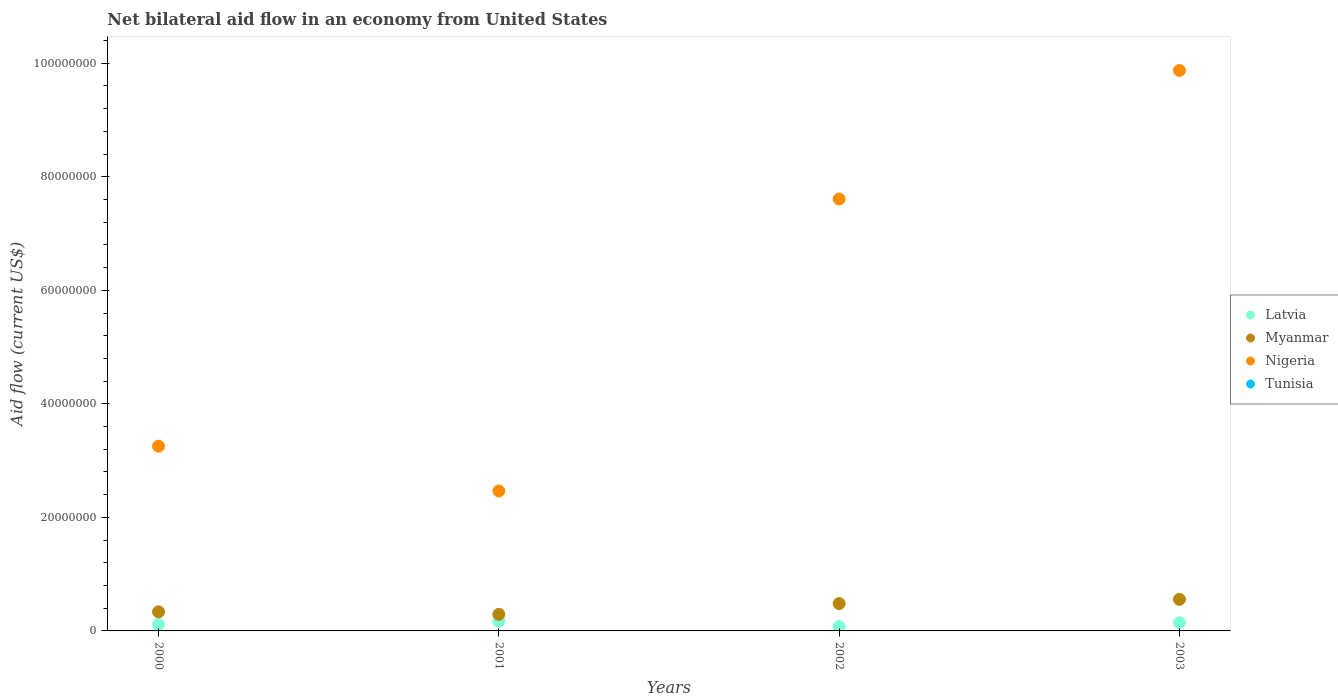How many different coloured dotlines are there?
Offer a terse response. 3. What is the net bilateral aid flow in Myanmar in 2001?
Provide a short and direct response. 2.93e+06. Across all years, what is the maximum net bilateral aid flow in Myanmar?
Provide a succinct answer. 5.56e+06. Across all years, what is the minimum net bilateral aid flow in Myanmar?
Make the answer very short. 2.93e+06. In which year was the net bilateral aid flow in Nigeria maximum?
Ensure brevity in your answer.  2003. What is the difference between the net bilateral aid flow in Tunisia in 2003 and the net bilateral aid flow in Nigeria in 2000?
Your response must be concise. -3.25e+07. What is the average net bilateral aid flow in Latvia per year?
Provide a succinct answer. 1.28e+06. In the year 2001, what is the difference between the net bilateral aid flow in Myanmar and net bilateral aid flow in Latvia?
Your answer should be very brief. 1.22e+06. In how many years, is the net bilateral aid flow in Latvia greater than 16000000 US$?
Offer a terse response. 0. What is the ratio of the net bilateral aid flow in Myanmar in 2000 to that in 2002?
Keep it short and to the point. 0.7. Is the difference between the net bilateral aid flow in Myanmar in 2001 and 2002 greater than the difference between the net bilateral aid flow in Latvia in 2001 and 2002?
Ensure brevity in your answer.  No. What is the difference between the highest and the second highest net bilateral aid flow in Nigeria?
Your answer should be compact. 2.26e+07. What is the difference between the highest and the lowest net bilateral aid flow in Myanmar?
Your answer should be compact. 2.63e+06. In how many years, is the net bilateral aid flow in Tunisia greater than the average net bilateral aid flow in Tunisia taken over all years?
Ensure brevity in your answer.  0. Is the sum of the net bilateral aid flow in Myanmar in 2001 and 2003 greater than the maximum net bilateral aid flow in Nigeria across all years?
Offer a terse response. No. Is it the case that in every year, the sum of the net bilateral aid flow in Nigeria and net bilateral aid flow in Myanmar  is greater than the sum of net bilateral aid flow in Tunisia and net bilateral aid flow in Latvia?
Provide a succinct answer. Yes. How many dotlines are there?
Provide a short and direct response. 3. How many years are there in the graph?
Your answer should be very brief. 4. What is the difference between two consecutive major ticks on the Y-axis?
Keep it short and to the point. 2.00e+07. How many legend labels are there?
Make the answer very short. 4. How are the legend labels stacked?
Ensure brevity in your answer.  Vertical. What is the title of the graph?
Your response must be concise. Net bilateral aid flow in an economy from United States. What is the Aid flow (current US$) in Latvia in 2000?
Offer a terse response. 1.15e+06. What is the Aid flow (current US$) in Myanmar in 2000?
Provide a short and direct response. 3.36e+06. What is the Aid flow (current US$) in Nigeria in 2000?
Your response must be concise. 3.25e+07. What is the Aid flow (current US$) of Tunisia in 2000?
Give a very brief answer. 0. What is the Aid flow (current US$) of Latvia in 2001?
Provide a succinct answer. 1.71e+06. What is the Aid flow (current US$) in Myanmar in 2001?
Your answer should be very brief. 2.93e+06. What is the Aid flow (current US$) in Nigeria in 2001?
Your answer should be very brief. 2.46e+07. What is the Aid flow (current US$) of Latvia in 2002?
Offer a very short reply. 8.10e+05. What is the Aid flow (current US$) in Myanmar in 2002?
Your response must be concise. 4.82e+06. What is the Aid flow (current US$) of Nigeria in 2002?
Ensure brevity in your answer.  7.61e+07. What is the Aid flow (current US$) of Latvia in 2003?
Provide a short and direct response. 1.45e+06. What is the Aid flow (current US$) of Myanmar in 2003?
Offer a very short reply. 5.56e+06. What is the Aid flow (current US$) in Nigeria in 2003?
Give a very brief answer. 9.87e+07. Across all years, what is the maximum Aid flow (current US$) in Latvia?
Keep it short and to the point. 1.71e+06. Across all years, what is the maximum Aid flow (current US$) of Myanmar?
Provide a short and direct response. 5.56e+06. Across all years, what is the maximum Aid flow (current US$) in Nigeria?
Make the answer very short. 9.87e+07. Across all years, what is the minimum Aid flow (current US$) in Latvia?
Give a very brief answer. 8.10e+05. Across all years, what is the minimum Aid flow (current US$) in Myanmar?
Provide a short and direct response. 2.93e+06. Across all years, what is the minimum Aid flow (current US$) in Nigeria?
Your response must be concise. 2.46e+07. What is the total Aid flow (current US$) in Latvia in the graph?
Offer a terse response. 5.12e+06. What is the total Aid flow (current US$) of Myanmar in the graph?
Make the answer very short. 1.67e+07. What is the total Aid flow (current US$) in Nigeria in the graph?
Ensure brevity in your answer.  2.32e+08. What is the total Aid flow (current US$) of Tunisia in the graph?
Give a very brief answer. 0. What is the difference between the Aid flow (current US$) of Latvia in 2000 and that in 2001?
Ensure brevity in your answer.  -5.60e+05. What is the difference between the Aid flow (current US$) in Nigeria in 2000 and that in 2001?
Make the answer very short. 7.88e+06. What is the difference between the Aid flow (current US$) of Latvia in 2000 and that in 2002?
Your answer should be compact. 3.40e+05. What is the difference between the Aid flow (current US$) in Myanmar in 2000 and that in 2002?
Your response must be concise. -1.46e+06. What is the difference between the Aid flow (current US$) in Nigeria in 2000 and that in 2002?
Your answer should be very brief. -4.36e+07. What is the difference between the Aid flow (current US$) in Myanmar in 2000 and that in 2003?
Make the answer very short. -2.20e+06. What is the difference between the Aid flow (current US$) of Nigeria in 2000 and that in 2003?
Your answer should be compact. -6.62e+07. What is the difference between the Aid flow (current US$) in Myanmar in 2001 and that in 2002?
Your answer should be very brief. -1.89e+06. What is the difference between the Aid flow (current US$) in Nigeria in 2001 and that in 2002?
Ensure brevity in your answer.  -5.14e+07. What is the difference between the Aid flow (current US$) in Myanmar in 2001 and that in 2003?
Ensure brevity in your answer.  -2.63e+06. What is the difference between the Aid flow (current US$) of Nigeria in 2001 and that in 2003?
Offer a very short reply. -7.41e+07. What is the difference between the Aid flow (current US$) of Latvia in 2002 and that in 2003?
Give a very brief answer. -6.40e+05. What is the difference between the Aid flow (current US$) in Myanmar in 2002 and that in 2003?
Provide a succinct answer. -7.40e+05. What is the difference between the Aid flow (current US$) in Nigeria in 2002 and that in 2003?
Your answer should be very brief. -2.26e+07. What is the difference between the Aid flow (current US$) of Latvia in 2000 and the Aid flow (current US$) of Myanmar in 2001?
Provide a short and direct response. -1.78e+06. What is the difference between the Aid flow (current US$) of Latvia in 2000 and the Aid flow (current US$) of Nigeria in 2001?
Keep it short and to the point. -2.35e+07. What is the difference between the Aid flow (current US$) of Myanmar in 2000 and the Aid flow (current US$) of Nigeria in 2001?
Your answer should be compact. -2.13e+07. What is the difference between the Aid flow (current US$) in Latvia in 2000 and the Aid flow (current US$) in Myanmar in 2002?
Your response must be concise. -3.67e+06. What is the difference between the Aid flow (current US$) of Latvia in 2000 and the Aid flow (current US$) of Nigeria in 2002?
Offer a terse response. -7.49e+07. What is the difference between the Aid flow (current US$) of Myanmar in 2000 and the Aid flow (current US$) of Nigeria in 2002?
Give a very brief answer. -7.27e+07. What is the difference between the Aid flow (current US$) in Latvia in 2000 and the Aid flow (current US$) in Myanmar in 2003?
Your answer should be compact. -4.41e+06. What is the difference between the Aid flow (current US$) in Latvia in 2000 and the Aid flow (current US$) in Nigeria in 2003?
Make the answer very short. -9.76e+07. What is the difference between the Aid flow (current US$) in Myanmar in 2000 and the Aid flow (current US$) in Nigeria in 2003?
Your response must be concise. -9.54e+07. What is the difference between the Aid flow (current US$) in Latvia in 2001 and the Aid flow (current US$) in Myanmar in 2002?
Offer a very short reply. -3.11e+06. What is the difference between the Aid flow (current US$) of Latvia in 2001 and the Aid flow (current US$) of Nigeria in 2002?
Offer a very short reply. -7.44e+07. What is the difference between the Aid flow (current US$) of Myanmar in 2001 and the Aid flow (current US$) of Nigeria in 2002?
Offer a very short reply. -7.32e+07. What is the difference between the Aid flow (current US$) in Latvia in 2001 and the Aid flow (current US$) in Myanmar in 2003?
Provide a short and direct response. -3.85e+06. What is the difference between the Aid flow (current US$) of Latvia in 2001 and the Aid flow (current US$) of Nigeria in 2003?
Your answer should be very brief. -9.70e+07. What is the difference between the Aid flow (current US$) in Myanmar in 2001 and the Aid flow (current US$) in Nigeria in 2003?
Offer a very short reply. -9.58e+07. What is the difference between the Aid flow (current US$) of Latvia in 2002 and the Aid flow (current US$) of Myanmar in 2003?
Give a very brief answer. -4.75e+06. What is the difference between the Aid flow (current US$) of Latvia in 2002 and the Aid flow (current US$) of Nigeria in 2003?
Your response must be concise. -9.79e+07. What is the difference between the Aid flow (current US$) in Myanmar in 2002 and the Aid flow (current US$) in Nigeria in 2003?
Your answer should be very brief. -9.39e+07. What is the average Aid flow (current US$) of Latvia per year?
Ensure brevity in your answer.  1.28e+06. What is the average Aid flow (current US$) of Myanmar per year?
Your answer should be very brief. 4.17e+06. What is the average Aid flow (current US$) of Nigeria per year?
Give a very brief answer. 5.80e+07. In the year 2000, what is the difference between the Aid flow (current US$) in Latvia and Aid flow (current US$) in Myanmar?
Ensure brevity in your answer.  -2.21e+06. In the year 2000, what is the difference between the Aid flow (current US$) of Latvia and Aid flow (current US$) of Nigeria?
Provide a short and direct response. -3.14e+07. In the year 2000, what is the difference between the Aid flow (current US$) of Myanmar and Aid flow (current US$) of Nigeria?
Offer a terse response. -2.92e+07. In the year 2001, what is the difference between the Aid flow (current US$) in Latvia and Aid flow (current US$) in Myanmar?
Offer a terse response. -1.22e+06. In the year 2001, what is the difference between the Aid flow (current US$) in Latvia and Aid flow (current US$) in Nigeria?
Provide a short and direct response. -2.29e+07. In the year 2001, what is the difference between the Aid flow (current US$) in Myanmar and Aid flow (current US$) in Nigeria?
Give a very brief answer. -2.17e+07. In the year 2002, what is the difference between the Aid flow (current US$) in Latvia and Aid flow (current US$) in Myanmar?
Your answer should be compact. -4.01e+06. In the year 2002, what is the difference between the Aid flow (current US$) of Latvia and Aid flow (current US$) of Nigeria?
Provide a short and direct response. -7.53e+07. In the year 2002, what is the difference between the Aid flow (current US$) in Myanmar and Aid flow (current US$) in Nigeria?
Your answer should be very brief. -7.13e+07. In the year 2003, what is the difference between the Aid flow (current US$) of Latvia and Aid flow (current US$) of Myanmar?
Make the answer very short. -4.11e+06. In the year 2003, what is the difference between the Aid flow (current US$) of Latvia and Aid flow (current US$) of Nigeria?
Your response must be concise. -9.73e+07. In the year 2003, what is the difference between the Aid flow (current US$) in Myanmar and Aid flow (current US$) in Nigeria?
Provide a succinct answer. -9.32e+07. What is the ratio of the Aid flow (current US$) in Latvia in 2000 to that in 2001?
Keep it short and to the point. 0.67. What is the ratio of the Aid flow (current US$) of Myanmar in 2000 to that in 2001?
Keep it short and to the point. 1.15. What is the ratio of the Aid flow (current US$) in Nigeria in 2000 to that in 2001?
Keep it short and to the point. 1.32. What is the ratio of the Aid flow (current US$) in Latvia in 2000 to that in 2002?
Provide a short and direct response. 1.42. What is the ratio of the Aid flow (current US$) of Myanmar in 2000 to that in 2002?
Ensure brevity in your answer.  0.7. What is the ratio of the Aid flow (current US$) of Nigeria in 2000 to that in 2002?
Your response must be concise. 0.43. What is the ratio of the Aid flow (current US$) of Latvia in 2000 to that in 2003?
Keep it short and to the point. 0.79. What is the ratio of the Aid flow (current US$) of Myanmar in 2000 to that in 2003?
Keep it short and to the point. 0.6. What is the ratio of the Aid flow (current US$) in Nigeria in 2000 to that in 2003?
Offer a terse response. 0.33. What is the ratio of the Aid flow (current US$) in Latvia in 2001 to that in 2002?
Offer a very short reply. 2.11. What is the ratio of the Aid flow (current US$) in Myanmar in 2001 to that in 2002?
Provide a succinct answer. 0.61. What is the ratio of the Aid flow (current US$) of Nigeria in 2001 to that in 2002?
Provide a short and direct response. 0.32. What is the ratio of the Aid flow (current US$) in Latvia in 2001 to that in 2003?
Ensure brevity in your answer.  1.18. What is the ratio of the Aid flow (current US$) in Myanmar in 2001 to that in 2003?
Your response must be concise. 0.53. What is the ratio of the Aid flow (current US$) of Nigeria in 2001 to that in 2003?
Ensure brevity in your answer.  0.25. What is the ratio of the Aid flow (current US$) in Latvia in 2002 to that in 2003?
Offer a very short reply. 0.56. What is the ratio of the Aid flow (current US$) of Myanmar in 2002 to that in 2003?
Offer a very short reply. 0.87. What is the ratio of the Aid flow (current US$) in Nigeria in 2002 to that in 2003?
Your answer should be very brief. 0.77. What is the difference between the highest and the second highest Aid flow (current US$) in Myanmar?
Your response must be concise. 7.40e+05. What is the difference between the highest and the second highest Aid flow (current US$) of Nigeria?
Keep it short and to the point. 2.26e+07. What is the difference between the highest and the lowest Aid flow (current US$) in Latvia?
Make the answer very short. 9.00e+05. What is the difference between the highest and the lowest Aid flow (current US$) in Myanmar?
Give a very brief answer. 2.63e+06. What is the difference between the highest and the lowest Aid flow (current US$) in Nigeria?
Keep it short and to the point. 7.41e+07. 